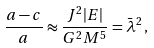Convert formula to latex. <formula><loc_0><loc_0><loc_500><loc_500>\frac { a - c } { a } \approx \frac { J ^ { 2 } | E | } { G ^ { 2 } M ^ { 5 } } = \bar { \lambda } ^ { 2 } \, ,</formula> 